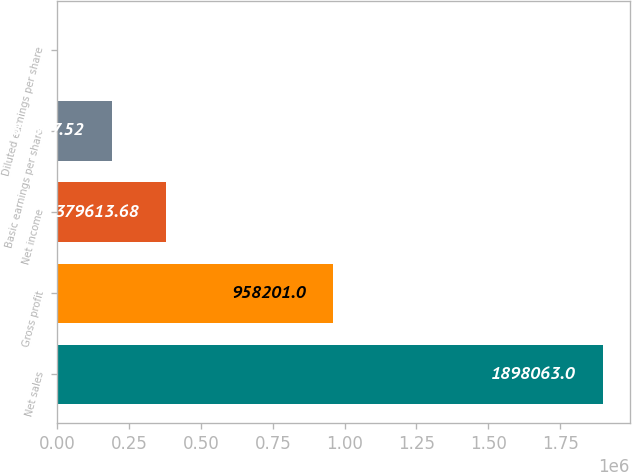<chart> <loc_0><loc_0><loc_500><loc_500><bar_chart><fcel>Net sales<fcel>Gross profit<fcel>Net income<fcel>Basic earnings per share<fcel>Diluted earnings per share<nl><fcel>1.89806e+06<fcel>958201<fcel>379614<fcel>189808<fcel>1.35<nl></chart> 